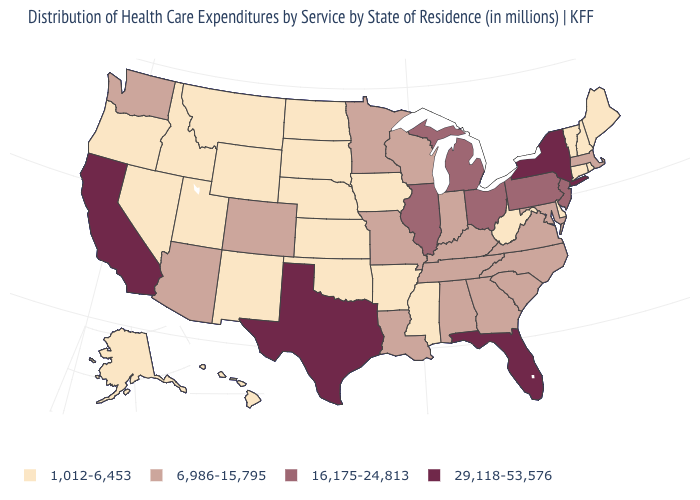Is the legend a continuous bar?
Give a very brief answer. No. What is the highest value in the USA?
Concise answer only. 29,118-53,576. Is the legend a continuous bar?
Concise answer only. No. How many symbols are there in the legend?
Concise answer only. 4. Is the legend a continuous bar?
Give a very brief answer. No. Which states have the lowest value in the USA?
Keep it brief. Alaska, Arkansas, Connecticut, Delaware, Hawaii, Idaho, Iowa, Kansas, Maine, Mississippi, Montana, Nebraska, Nevada, New Hampshire, New Mexico, North Dakota, Oklahoma, Oregon, Rhode Island, South Dakota, Utah, Vermont, West Virginia, Wyoming. Does the first symbol in the legend represent the smallest category?
Quick response, please. Yes. Does the first symbol in the legend represent the smallest category?
Write a very short answer. Yes. How many symbols are there in the legend?
Answer briefly. 4. Does Florida have a higher value than Texas?
Concise answer only. No. Does Nebraska have a lower value than Connecticut?
Concise answer only. No. What is the lowest value in the Northeast?
Keep it brief. 1,012-6,453. Does Virginia have the highest value in the South?
Write a very short answer. No. What is the value of Nevada?
Keep it brief. 1,012-6,453. Name the states that have a value in the range 29,118-53,576?
Give a very brief answer. California, Florida, New York, Texas. 